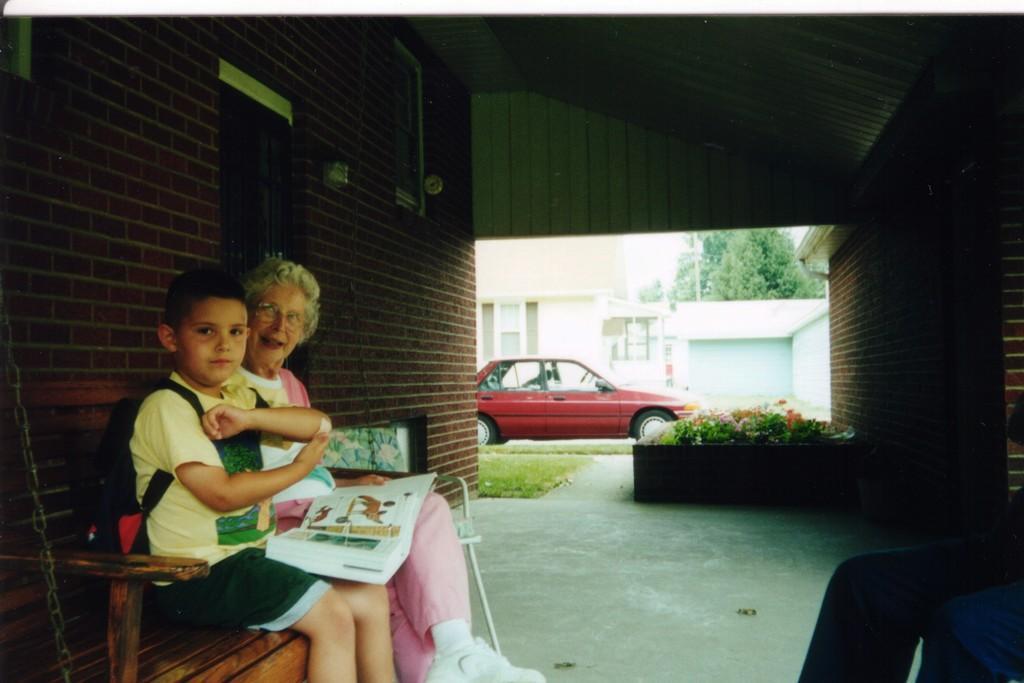Can you describe this image briefly? In this image I can see two persons are sitting on a bench on the left side. In the background I can see few plants, a red colour car, few buildings and a tree. I can also see she is holding a book. 